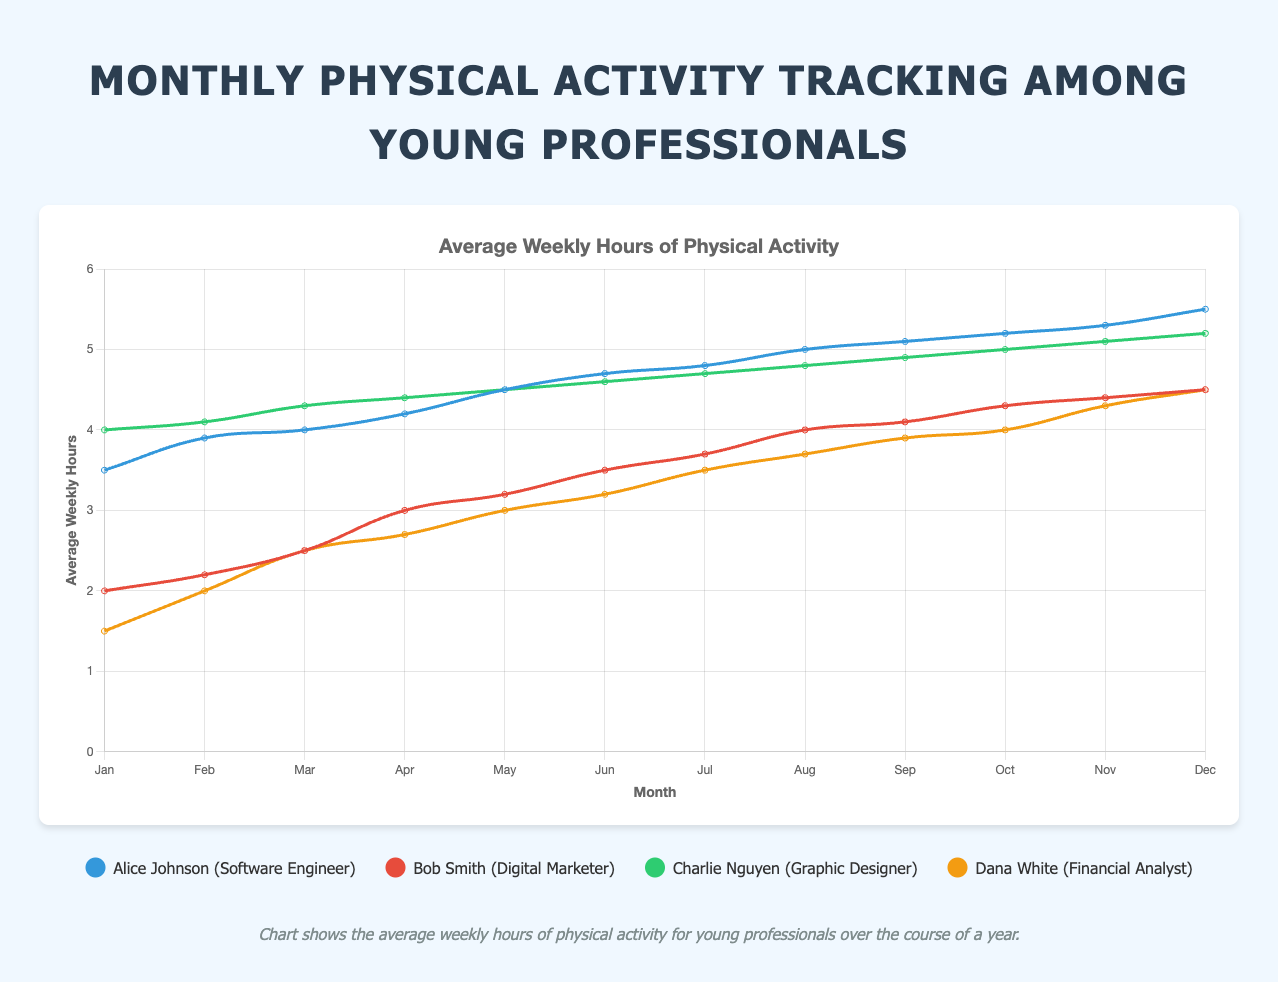How does the average weekly physical activity of Alice change from January to December? Alice Johnson's average weekly hours start at 3.5 in January and increase every month. By December, her average weekly hours reach 5.5. This shows a consistent upward trend throughout the year.
Answer: It increases from 3.5 to 5.5 In which month does Dana have the highest average weekly physical activity? Looking at Dana White's curve, the highest point is in December with an average weekly activity of 4.5 hours.
Answer: December Compare the average weekly physical activity of Bob and Charlie in May. Who is more active? In May, Bob Smith's average weekly hours are 3.2, while Charlie Nguyen's are 4.5. Charlie is more active.
Answer: Charlie Nguyen Which participant shows the most significant increase in average weekly hours from January to June? From the data, Dana White has a jump from 1.5 hours in January to 3.2 in June, which is a 1.7-hour increase. However, Alice Johnson shows a rise from 3.5 to 4.7, which is more than Dana's increase by 1.2. Thus, Alice has the most significant increase.
Answer: Alice Johnson Calculate the overall average weekly hours of all participants in October. Add up the average weekly hours of all participants in October (5.2 for Alice, 4.3 for Bob, 5.0 for Charlie, and 4.0 for Dana) and divide by the number of participants (4). The sum is 18.5, so the average is 18.5 / 4 = 4.625.
Answer: 4.625 Which individual shows the least variation in their weekly activity throughout the year? By analyzing the smoothness and slope of the curves, Charlie Nguyen's curve shows the least variation, with consistent increases every month.
Answer: Charlie Nguyen In which month do the average weekly hours of Bob and Dana equal each other? Bob Smith and Dana White both have an average weekly activity of 4.5 hours in December.
Answer: December How much did the weekly activity of Charlie increase from March to July? Charlie's average weekly hours in March are 4.3, and in July, it's 4.7. The increase is 4.7 - 4.3 = 0.4 hours.
Answer: 0.4 hours Who had the second highest average weekly hours in February and what was their activity? Charlie Nguyen had the second-highest average weekly hours in February with 4.1 hours, just below Alice Johnson.
Answer: Charlie Nguyen, 4.1 hours 